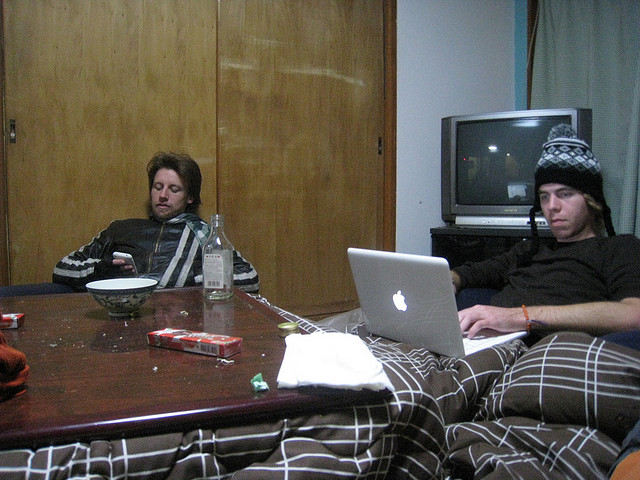<image>What gaming system are the people playing? It is ambiguous as to which gaming system the people are playing. They might be on a PC, a Mac, or a laptop. What gaming system are the people playing? I don't know what gaming system the people are playing. There is no clear indication in the answers. 